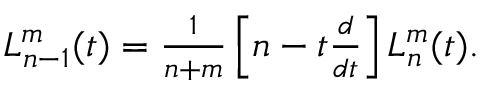Convert formula to latex. <formula><loc_0><loc_0><loc_500><loc_500>\begin{array} { r } { L _ { n - 1 } ^ { m } ( t ) = \frac { 1 } { n + m } \left [ n - t \frac { d } { d t } \right ] L _ { n } ^ { m } ( t ) . } \end{array}</formula> 